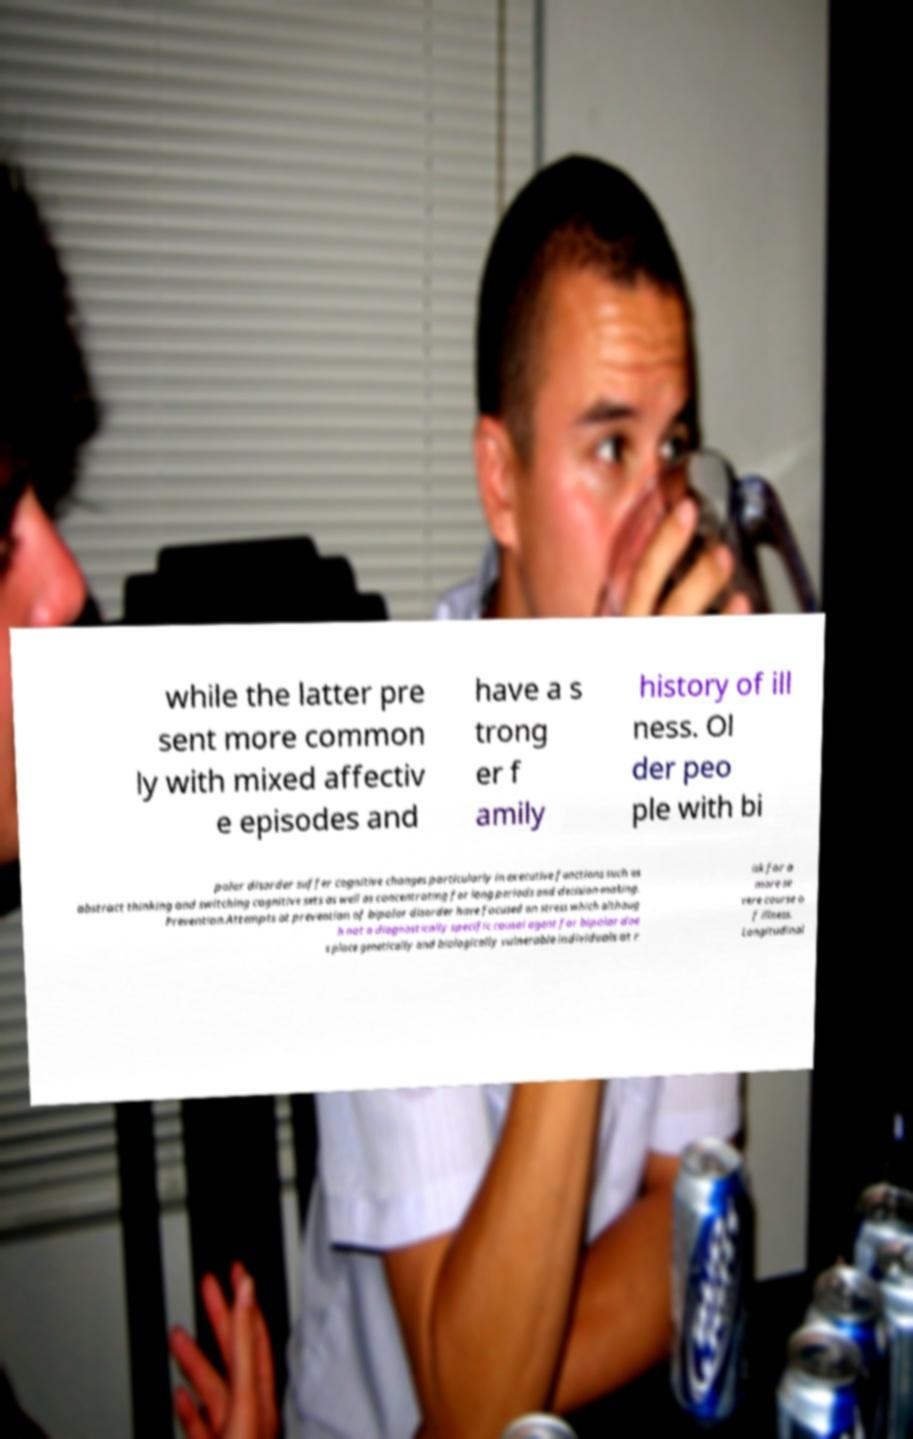There's text embedded in this image that I need extracted. Can you transcribe it verbatim? while the latter pre sent more common ly with mixed affectiv e episodes and have a s trong er f amily history of ill ness. Ol der peo ple with bi polar disorder suffer cognitive changes particularly in executive functions such as abstract thinking and switching cognitive sets as well as concentrating for long periods and decision-making. Prevention.Attempts at prevention of bipolar disorder have focused on stress which althoug h not a diagnostically specific causal agent for bipolar doe s place genetically and biologically vulnerable individuals at r isk for a more se vere course o f illness. Longitudinal 